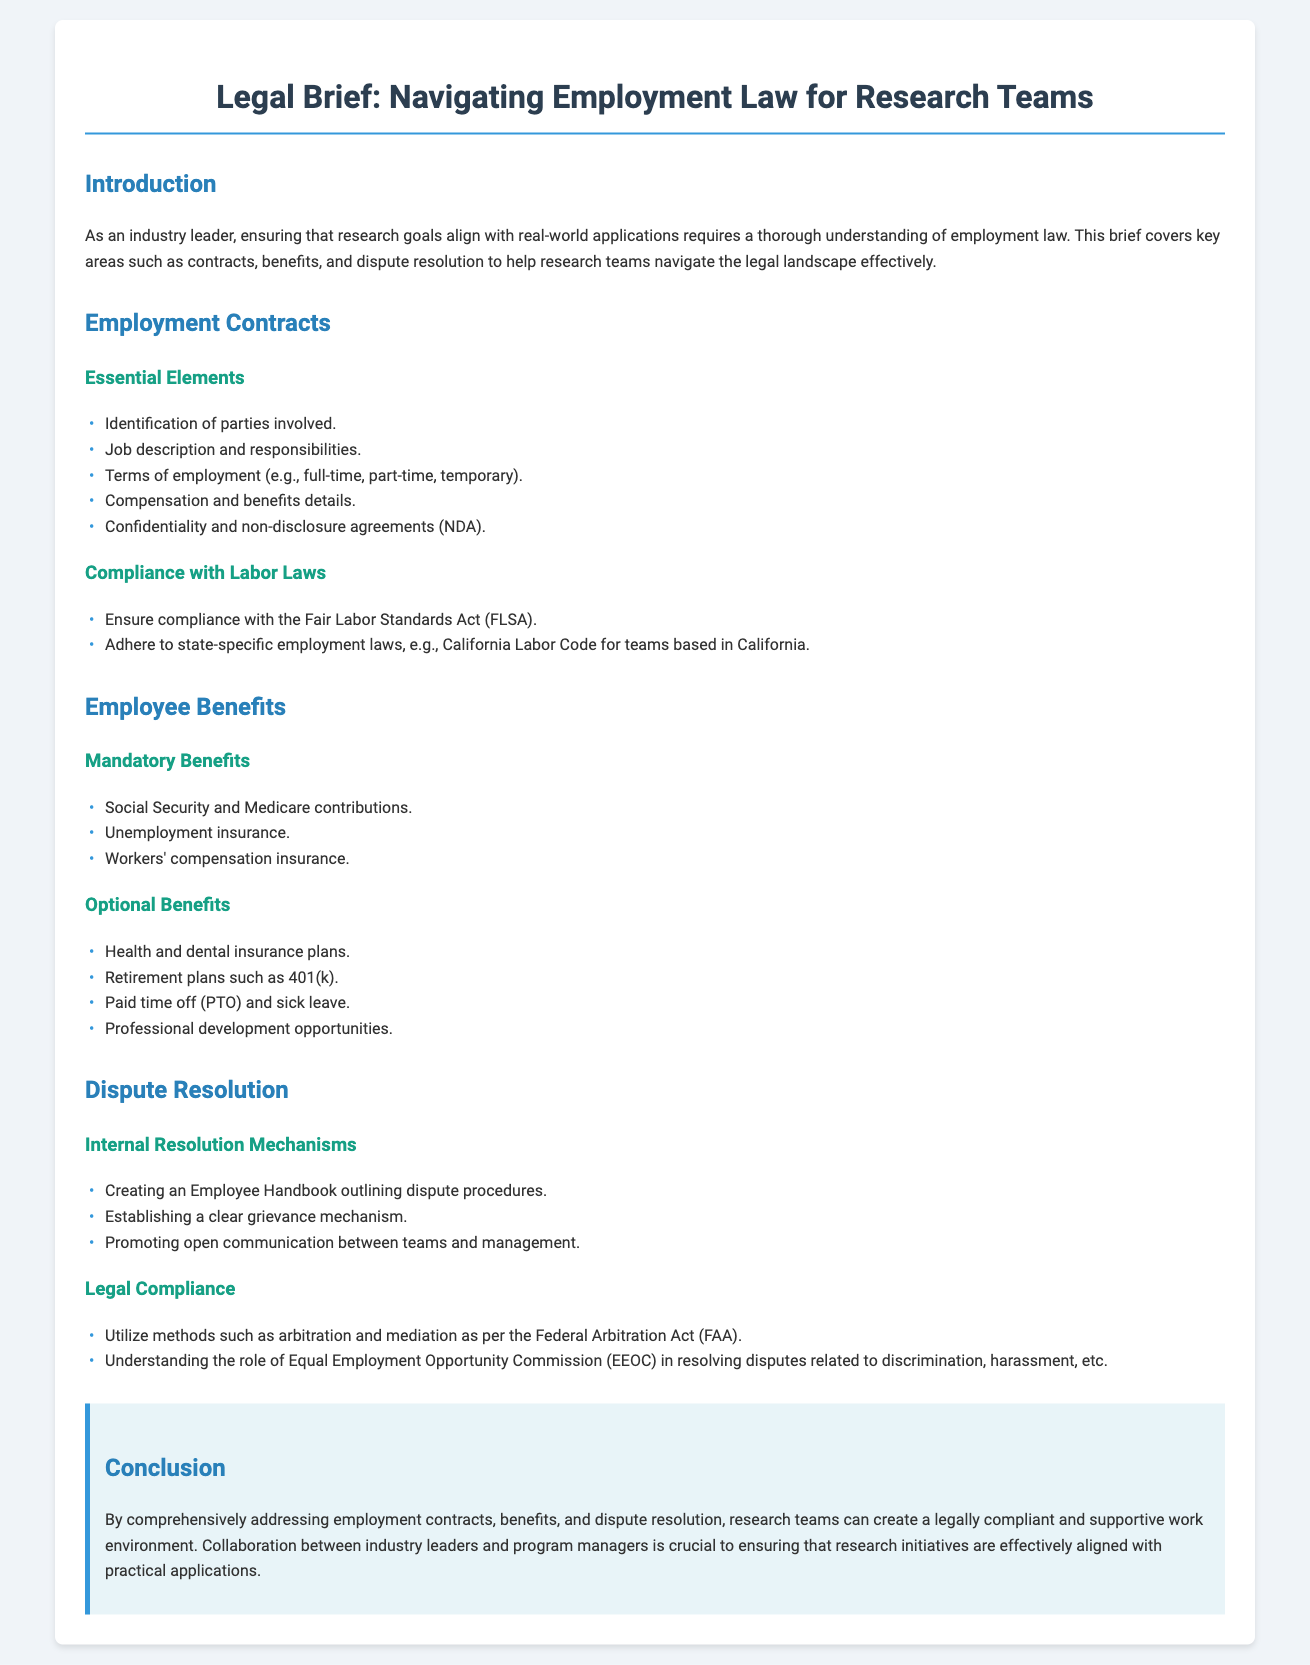what is the title of the document? The title of the document is mentioned at the very top, providing a clear indication of the subject matter.
Answer: Legal Brief: Navigating Employment Law for Research Teams how many essential elements are listed under Employment Contracts? The document lists five essential elements that make up employment contracts, which can be easily counted.
Answer: 5 name one mandatory employee benefit mentioned in the document. The text lists several mandatory benefits under Employee Benefits; any one of them can be taken as an answer.
Answer: Social Security what is one option listed under Optional Benefits? The document provides several examples of optional benefits; answering with any one of them fulfills this requirement.
Answer: Health and dental insurance plans what method is mentioned for internal dispute resolution? The text defines specific strategies for resolving disputes internally; selecting any one from the list qualifies as an answer.
Answer: Employee Handbook which act governs arbitration and mediation methods? The document refers to a specific legal framework that governs these resolution mechanisms.
Answer: Federal Arbitration Act how many types of dispute resolution mechanisms are detailed in the document? The document separates dispute resolution into internal and legal compliance mechanisms, which can be counted.
Answer: 2 which commission is mentioned in relation to dispute resolution? The document explicitly states a specific commission involved in handling related disputes, providing a clear answer.
Answer: Equal Employment Opportunity Commission what is the primary focus of the legal brief? The summary at the end outlines the main objectives of the brief, emphasizing its purpose for research teams.
Answer: Employment contracts, benefits, and dispute resolution 